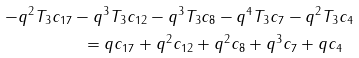<formula> <loc_0><loc_0><loc_500><loc_500>\ \ - q ^ { 2 } T _ { 3 } c _ { 1 7 } - q ^ { 3 } T _ { 3 } c _ { 1 2 } - q ^ { 3 } T _ { 3 } c _ { 8 } - q ^ { 4 } T _ { 3 } c _ { 7 } - q ^ { 2 } T _ { 3 } c _ { 4 } \\ = q c _ { 1 7 } + q ^ { 2 } c _ { 1 2 } + q ^ { 2 } c _ { 8 } + q ^ { 3 } c _ { 7 } + q c _ { 4 } \ \</formula> 